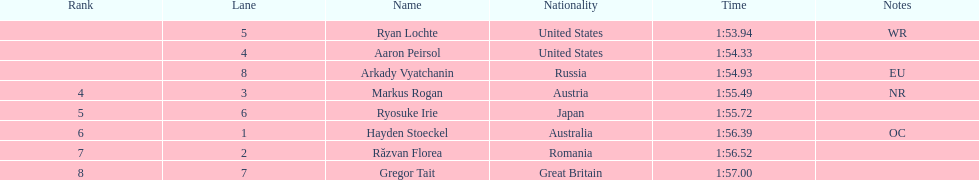In the competition, which nation secured the highest number of medals? United States. 